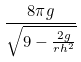Convert formula to latex. <formula><loc_0><loc_0><loc_500><loc_500>\frac { 8 \pi g } { \sqrt { 9 - \frac { 2 g } { r h ^ { 2 } } } }</formula> 